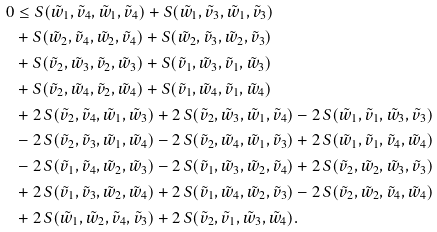<formula> <loc_0><loc_0><loc_500><loc_500>0 & \leq S ( \tilde { w } _ { 1 } , \tilde { v } _ { 4 } , \tilde { w } _ { 1 } , \tilde { v } _ { 4 } ) + S ( \tilde { w } _ { 1 } , \tilde { v } _ { 3 } , \tilde { w } _ { 1 } , \tilde { v } _ { 3 } ) \\ & + S ( \tilde { w } _ { 2 } , \tilde { v } _ { 4 } , \tilde { w } _ { 2 } , \tilde { v } _ { 4 } ) + S ( \tilde { w } _ { 2 } , \tilde { v } _ { 3 } , \tilde { w } _ { 2 } , \tilde { v } _ { 3 } ) \\ & + S ( \tilde { v } _ { 2 } , \tilde { w } _ { 3 } , \tilde { v } _ { 2 } , \tilde { w } _ { 3 } ) + S ( \tilde { v } _ { 1 } , \tilde { w } _ { 3 } , \tilde { v } _ { 1 } , \tilde { w } _ { 3 } ) \\ & + S ( \tilde { v } _ { 2 } , \tilde { w } _ { 4 } , \tilde { v } _ { 2 } , \tilde { w } _ { 4 } ) + S ( \tilde { v } _ { 1 } , \tilde { w } _ { 4 } , \tilde { v } _ { 1 } , \tilde { w } _ { 4 } ) \\ & + 2 \, S ( \tilde { v } _ { 2 } , \tilde { v } _ { 4 } , \tilde { w } _ { 1 } , \tilde { w } _ { 3 } ) + 2 \, S ( \tilde { v } _ { 2 } , \tilde { w } _ { 3 } , \tilde { w } _ { 1 } , \tilde { v } _ { 4 } ) - 2 \, S ( \tilde { w } _ { 1 } , \tilde { v } _ { 1 } , \tilde { w } _ { 3 } , \tilde { v } _ { 3 } ) \\ & - 2 \, S ( \tilde { v } _ { 2 } , \tilde { v } _ { 3 } , \tilde { w } _ { 1 } , \tilde { w } _ { 4 } ) - 2 \, S ( \tilde { v } _ { 2 } , \tilde { w } _ { 4 } , \tilde { w } _ { 1 } , \tilde { v } _ { 3 } ) + 2 \, S ( \tilde { w } _ { 1 } , \tilde { v } _ { 1 } , \tilde { v } _ { 4 } , \tilde { w } _ { 4 } ) \\ & - 2 \, S ( \tilde { v } _ { 1 } , \tilde { v } _ { 4 } , \tilde { w } _ { 2 } , \tilde { w } _ { 3 } ) - 2 \, S ( \tilde { v } _ { 1 } , \tilde { w } _ { 3 } , \tilde { w } _ { 2 } , \tilde { v } _ { 4 } ) + 2 \, S ( \tilde { v } _ { 2 } , \tilde { w } _ { 2 } , \tilde { w } _ { 3 } , \tilde { v } _ { 3 } ) \\ & + 2 \, S ( \tilde { v } _ { 1 } , \tilde { v } _ { 3 } , \tilde { w } _ { 2 } , \tilde { w } _ { 4 } ) + 2 \, S ( \tilde { v } _ { 1 } , \tilde { w } _ { 4 } , \tilde { w } _ { 2 } , \tilde { v } _ { 3 } ) - 2 \, S ( \tilde { v } _ { 2 } , \tilde { w } _ { 2 } , \tilde { v } _ { 4 } , \tilde { w } _ { 4 } ) \\ & + 2 \, S ( \tilde { w } _ { 1 } , \tilde { w } _ { 2 } , \tilde { v } _ { 4 } , \tilde { v } _ { 3 } ) + 2 \, S ( \tilde { v } _ { 2 } , \tilde { v } _ { 1 } , \tilde { w } _ { 3 } , \tilde { w } _ { 4 } ) .</formula> 